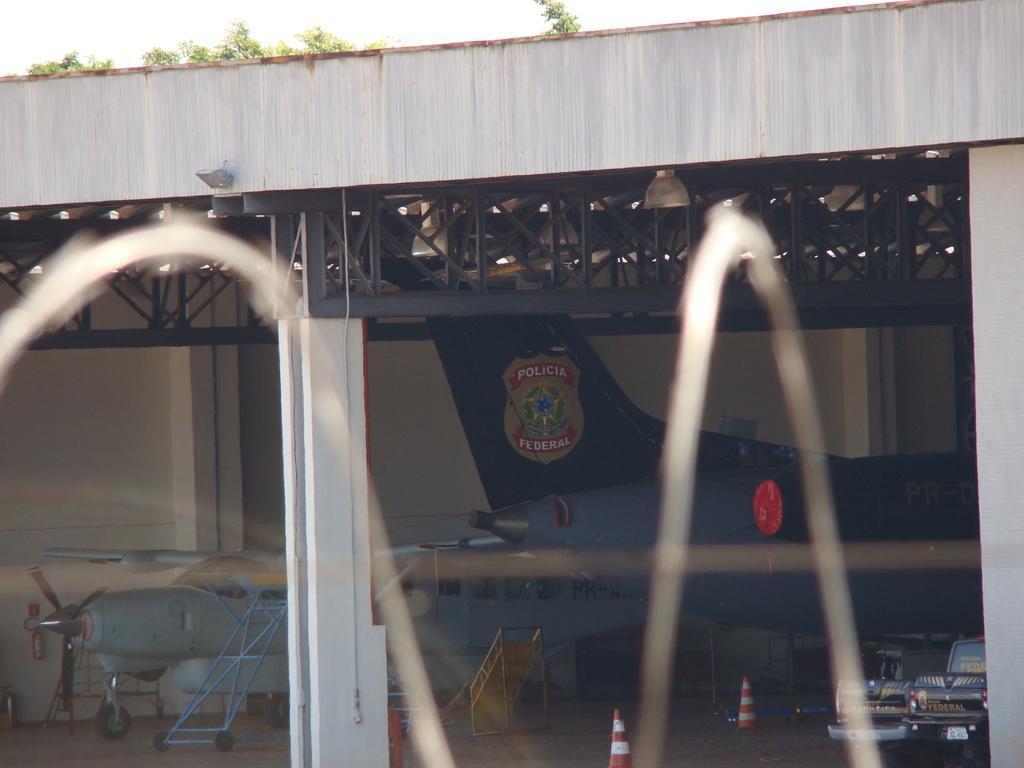How would you summarize this image in a sentence or two? In this picture we can see a bridge under which there are police aircrafts parked on the ground. 